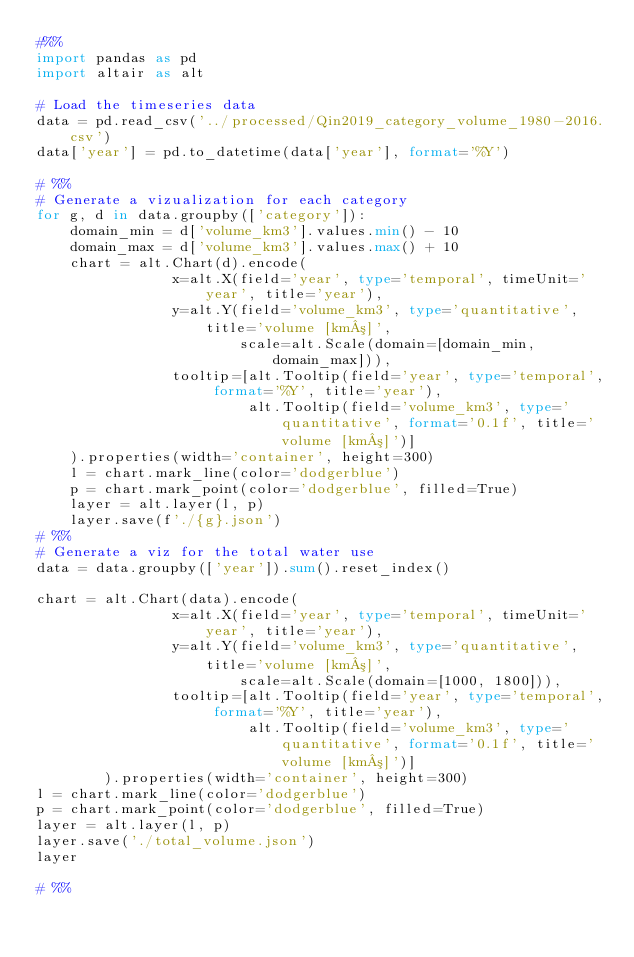<code> <loc_0><loc_0><loc_500><loc_500><_Python_>#%%
import pandas as pd 
import altair as alt 

# Load the timeseries data
data = pd.read_csv('../processed/Qin2019_category_volume_1980-2016.csv')
data['year'] = pd.to_datetime(data['year'], format='%Y')

# %%
# Generate a vizualization for each category
for g, d in data.groupby(['category']):        
    domain_min = d['volume_km3'].values.min() - 10
    domain_max = d['volume_km3'].values.max() + 10
    chart = alt.Chart(d).encode(
                x=alt.X(field='year', type='temporal', timeUnit='year', title='year'),
                y=alt.Y(field='volume_km3', type='quantitative', title='volume [km³]',
                        scale=alt.Scale(domain=[domain_min, domain_max])),
                tooltip=[alt.Tooltip(field='year', type='temporal', format='%Y', title='year'),
                         alt.Tooltip(field='volume_km3', type='quantitative', format='0.1f', title='volume [km³]')]
    ).properties(width='container', height=300)
    l = chart.mark_line(color='dodgerblue')
    p = chart.mark_point(color='dodgerblue', filled=True)
    layer = alt.layer(l, p)
    layer.save(f'./{g}.json')
# %%
# Generate a viz for the total water use
data = data.groupby(['year']).sum().reset_index()

chart = alt.Chart(data).encode(
                x=alt.X(field='year', type='temporal', timeUnit='year', title='year'),
                y=alt.Y(field='volume_km3', type='quantitative', title='volume [km³]',
                        scale=alt.Scale(domain=[1000, 1800])),
                tooltip=[alt.Tooltip(field='year', type='temporal', format='%Y', title='year'),
                         alt.Tooltip(field='volume_km3', type='quantitative', format='0.1f', title='volume [km³]')]
        ).properties(width='container', height=300)
l = chart.mark_line(color='dodgerblue')
p = chart.mark_point(color='dodgerblue', filled=True)
layer = alt.layer(l, p)
layer.save('./total_volume.json')
layer

# %%
</code> 